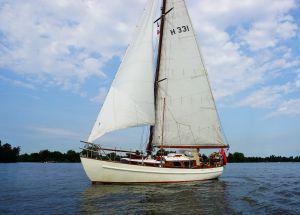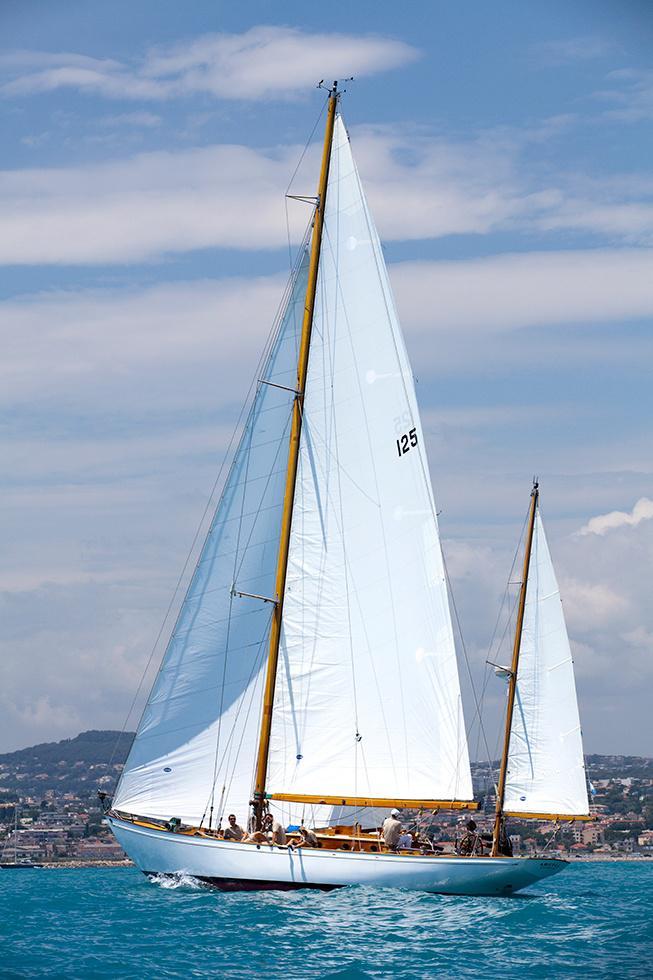The first image is the image on the left, the second image is the image on the right. For the images displayed, is the sentence "At least one of the ship has at least one sail that is not up." factually correct? Answer yes or no. No. The first image is the image on the left, the second image is the image on the right. Assess this claim about the two images: "There are no visible clouds in one of the images within the pair.". Correct or not? Answer yes or no. No. 